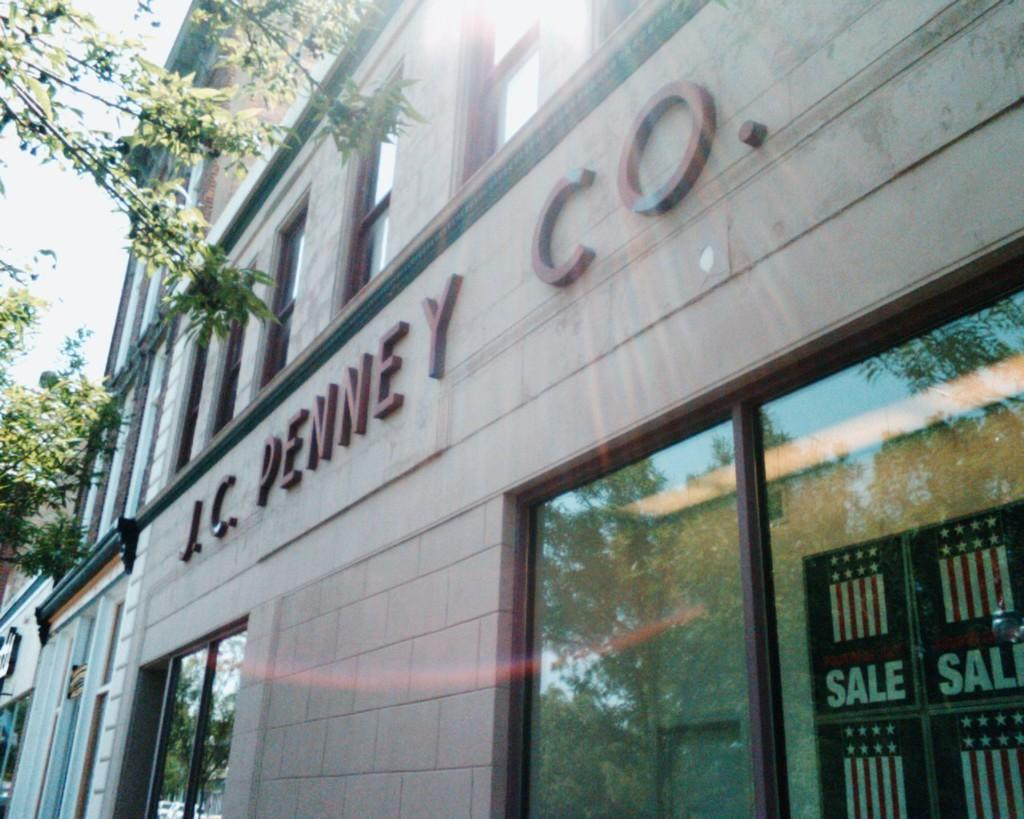What type of structure is present in the image? There is a building in the image. What can be seen on the building? There are names visible on the building. What type of natural elements are present in the background of the image? There are trees in the background of the image. What part of the natural environment is visible in the background of the image? The sky is visible in the background of the image. What type of polish is being used to clean the building in the image? There is no indication in the image that any polish is being used to clean the building. 